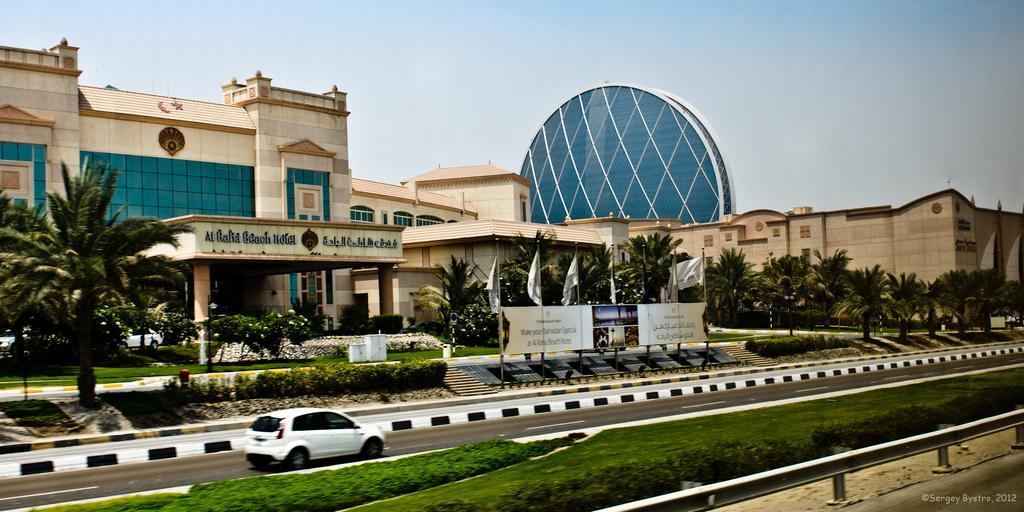Could you give a brief overview of what you see in this image? In this image we can see vehicle on the road. On the ground there is grass. Also there are plants. And there is a railing. In the back we can see trees. Also there is a banner. And there are flags with poles. In the background we can see buildings. And there is sky. 